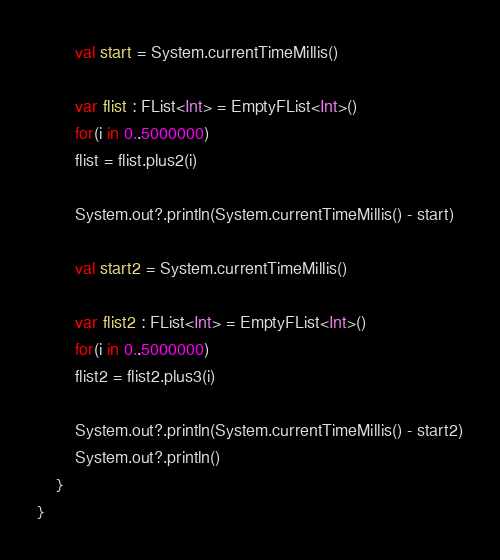Convert code to text. <code><loc_0><loc_0><loc_500><loc_500><_Kotlin_>        val start = System.currentTimeMillis()

        var flist : FList<Int> = EmptyFList<Int>()
        for(i in 0..5000000)
        flist = flist.plus2(i)

        System.out?.println(System.currentTimeMillis() - start)

        val start2 = System.currentTimeMillis()

        var flist2 : FList<Int> = EmptyFList<Int>()
        for(i in 0..5000000)
        flist2 = flist2.plus3(i)

        System.out?.println(System.currentTimeMillis() - start2)
        System.out?.println()
    }
}
</code> 